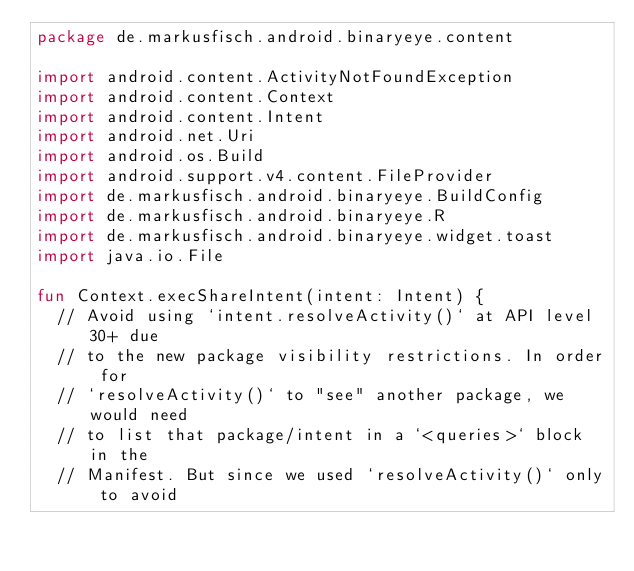Convert code to text. <code><loc_0><loc_0><loc_500><loc_500><_Kotlin_>package de.markusfisch.android.binaryeye.content

import android.content.ActivityNotFoundException
import android.content.Context
import android.content.Intent
import android.net.Uri
import android.os.Build
import android.support.v4.content.FileProvider
import de.markusfisch.android.binaryeye.BuildConfig
import de.markusfisch.android.binaryeye.R
import de.markusfisch.android.binaryeye.widget.toast
import java.io.File

fun Context.execShareIntent(intent: Intent) {
	// Avoid using `intent.resolveActivity()` at API level 30+ due
	// to the new package visibility restrictions. In order for
	// `resolveActivity()` to "see" another package, we would need
	// to list that package/intent in a `<queries>` block in the
	// Manifest. But since we used `resolveActivity()` only to avoid</code> 